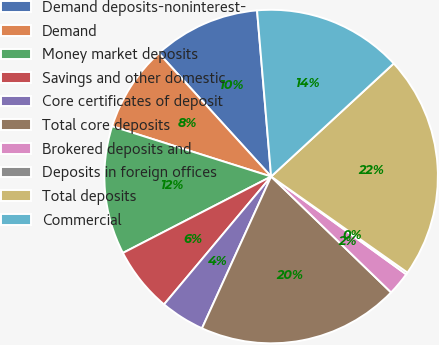Convert chart. <chart><loc_0><loc_0><loc_500><loc_500><pie_chart><fcel>Demand deposits-noninterest-<fcel>Demand<fcel>Money market deposits<fcel>Savings and other domestic<fcel>Core certificates of deposit<fcel>Total core deposits<fcel>Brokered deposits and<fcel>Deposits in foreign offices<fcel>Total deposits<fcel>Commercial<nl><fcel>10.41%<fcel>8.37%<fcel>12.45%<fcel>6.33%<fcel>4.29%<fcel>19.58%<fcel>2.25%<fcel>0.21%<fcel>21.62%<fcel>14.49%<nl></chart> 